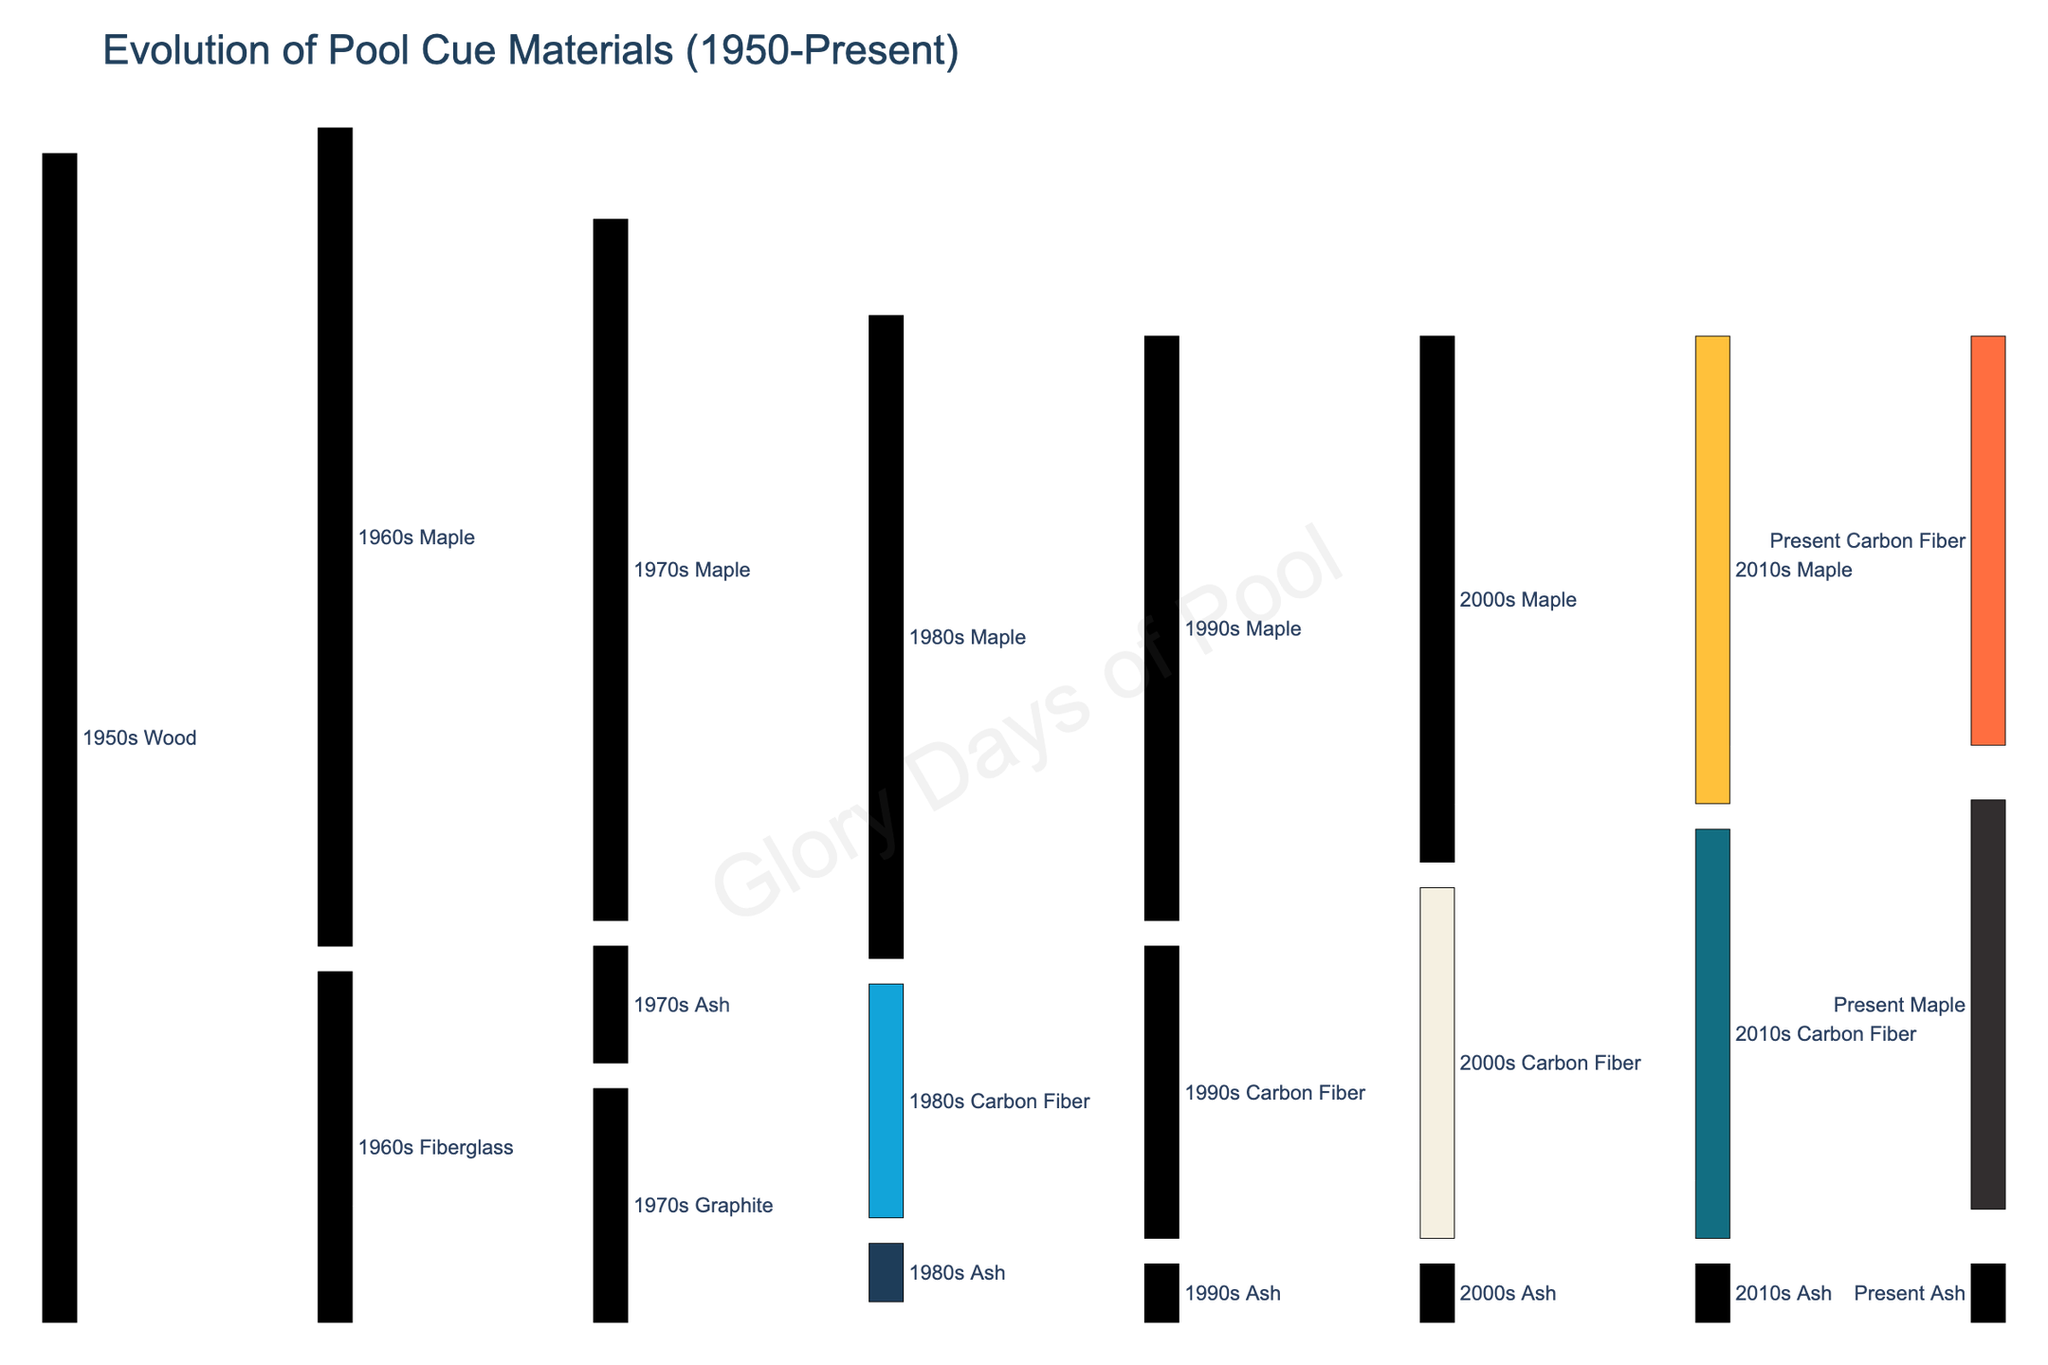What is the title of the Sankey diagram? The title is located at the top of the diagram and provides an overall description of what the figure represents. By looking at the title of the figure, we can know that it is about the evolution of pool cue materials from 1950 to the present.
Answer: Evolution of Pool Cue Materials (1950-Present) Which material was introduced in the 1970s and evolved to carbon fiber in the 1980s? By observing the flow from the 1970s to the 1980s, we can see that the material Graphite was introduced in the 1970s and some portion of it evolved to Carbon Fiber in the 1980s.
Answer: Graphite How many materials were present in the 2010s? By counting the labels in the 2010s section of the Sankey diagram, we see that there are three different materials represented in the 2010s: Carbon Fiber, Maple, and Ash.
Answer: Three Which material remains consistent from the 1950s up to the present without any changes? By tracking the flows visually from the initial point through to the present, we can see that Maple starts in the 1950s and continues consistently through every decade up to the present without changing materials.
Answer: Maple Compare the volume of Wood sources in the 1950s transitioning to Fiberglass in the 1960s with those transitioning to Maple in the 1960s. By examining the Sankey diagram, we can see two flows coming out from Wood in the 1950s. The flow to Fiberglass in the 1960s is labeled 30, while the flow to Maple in the 1960s is labeled 70.
Answer: Maple is greater Which material has the largest volume in the present era? By looking at the Sankey diagram, the thickness of the flows and the labels at the endpoint, we can determine that Carbon Fiber and Maple both have a flow value of 35, making them the materials with the largest volume in the present era.
Answer: Carbon Fiber and Maple Calculate the total volume of Maple cues in the 1980s. By adding the incoming flows to Maple in the 1980s, we have a flow of 55 from Maple in the 1970s. No other material flows into Maple in the 1980s, so the total volume is 55.
Answer: 55 What demonstrates the longest continuous lineage without changing materials? The Sankey diagram shows that the Maple material has a continuous lineage from the 1950s to the present without any changes, making it the longest continuous material flow.
Answer: Maple Compare the flow from Fiberglass in the 1960s to Graphite in the 1970s versus Graphite in the 1970s to Carbon Fiber in the 1980s. Which is greater? From the Sankey diagram, the flow from Fiberglass in the 1960s to Graphite in the 1970s is 20, and the flow from Graphite in the 1970s to Carbon Fiber in the 1980s is 15. Therefore, the flow from Fiberglass to Graphite is greater.
Answer: Fiberglass to Graphite Summarize the transition pattern of Carbon Fiber from its introduction to the present day. Carbon Fiber is introduced in the 1980s from Graphite, then it continues into the 1990s, 2000s, 2010s, and finally remains in the present day. This means Carbon Fiber has a continuous flow from its introduction to the present without any material change.
Answer: Continuous from 1980s to present 